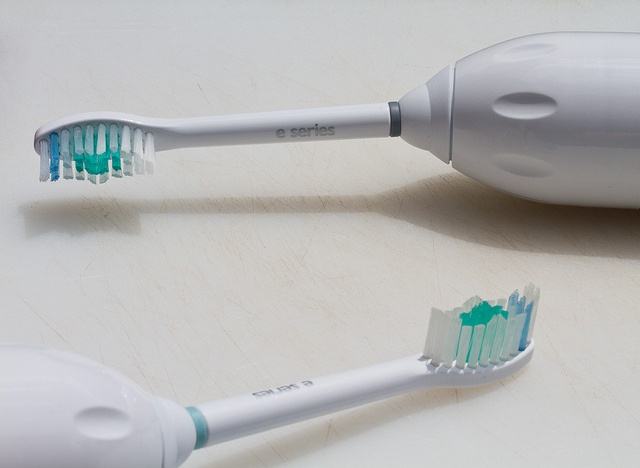Describe the objects in this image and their specific colors. I can see toothbrush in lightgray, darkgray, and gray tones and toothbrush in lightgray, darkgray, and teal tones in this image. 